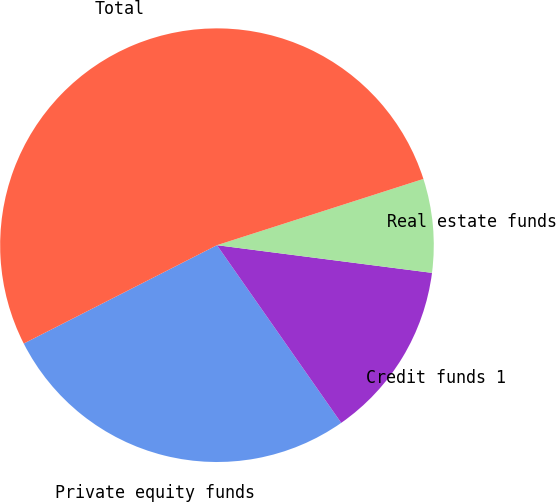Convert chart. <chart><loc_0><loc_0><loc_500><loc_500><pie_chart><fcel>Private equity funds<fcel>Credit funds 1<fcel>Real estate funds<fcel>Total<nl><fcel>27.22%<fcel>13.25%<fcel>6.98%<fcel>52.55%<nl></chart> 